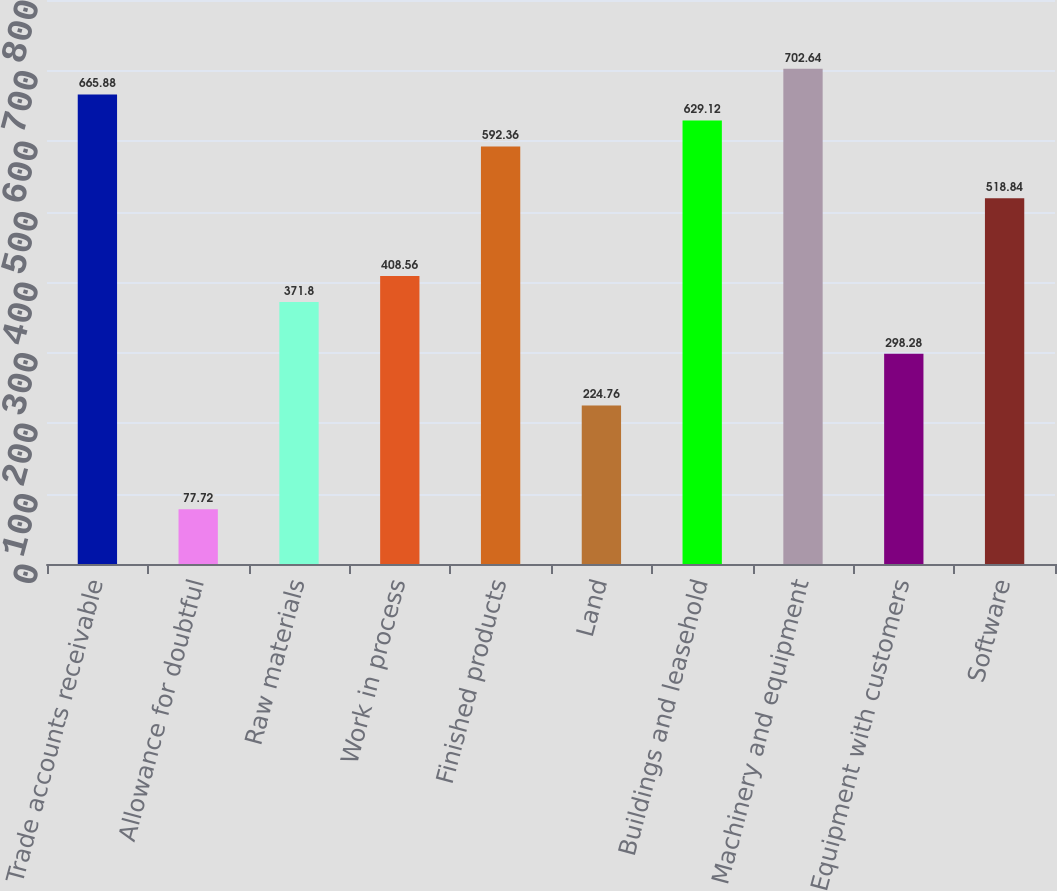<chart> <loc_0><loc_0><loc_500><loc_500><bar_chart><fcel>Trade accounts receivable<fcel>Allowance for doubtful<fcel>Raw materials<fcel>Work in process<fcel>Finished products<fcel>Land<fcel>Buildings and leasehold<fcel>Machinery and equipment<fcel>Equipment with customers<fcel>Software<nl><fcel>665.88<fcel>77.72<fcel>371.8<fcel>408.56<fcel>592.36<fcel>224.76<fcel>629.12<fcel>702.64<fcel>298.28<fcel>518.84<nl></chart> 